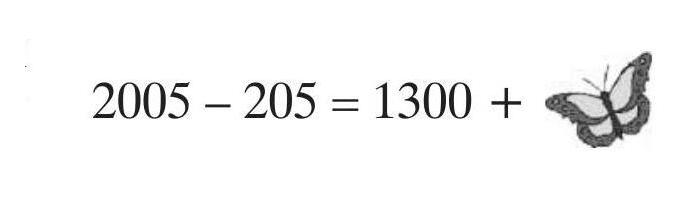A butterfly sat down on a correctly solved exercise. What number is the butterfly covering?
<image1> Choices: [] Answer is 500. 